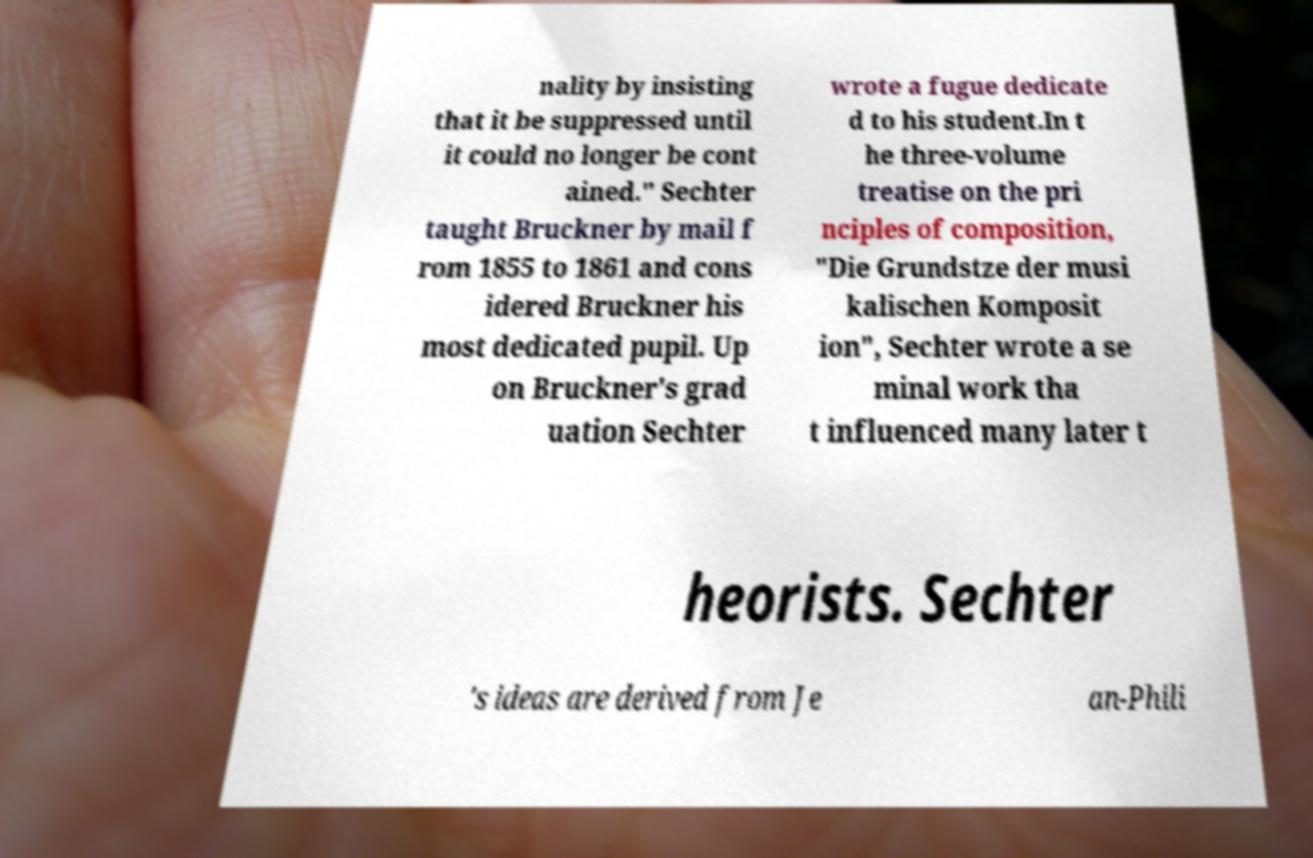I need the written content from this picture converted into text. Can you do that? nality by insisting that it be suppressed until it could no longer be cont ained." Sechter taught Bruckner by mail f rom 1855 to 1861 and cons idered Bruckner his most dedicated pupil. Up on Bruckner's grad uation Sechter wrote a fugue dedicate d to his student.In t he three-volume treatise on the pri nciples of composition, "Die Grundstze der musi kalischen Komposit ion", Sechter wrote a se minal work tha t influenced many later t heorists. Sechter 's ideas are derived from Je an-Phili 